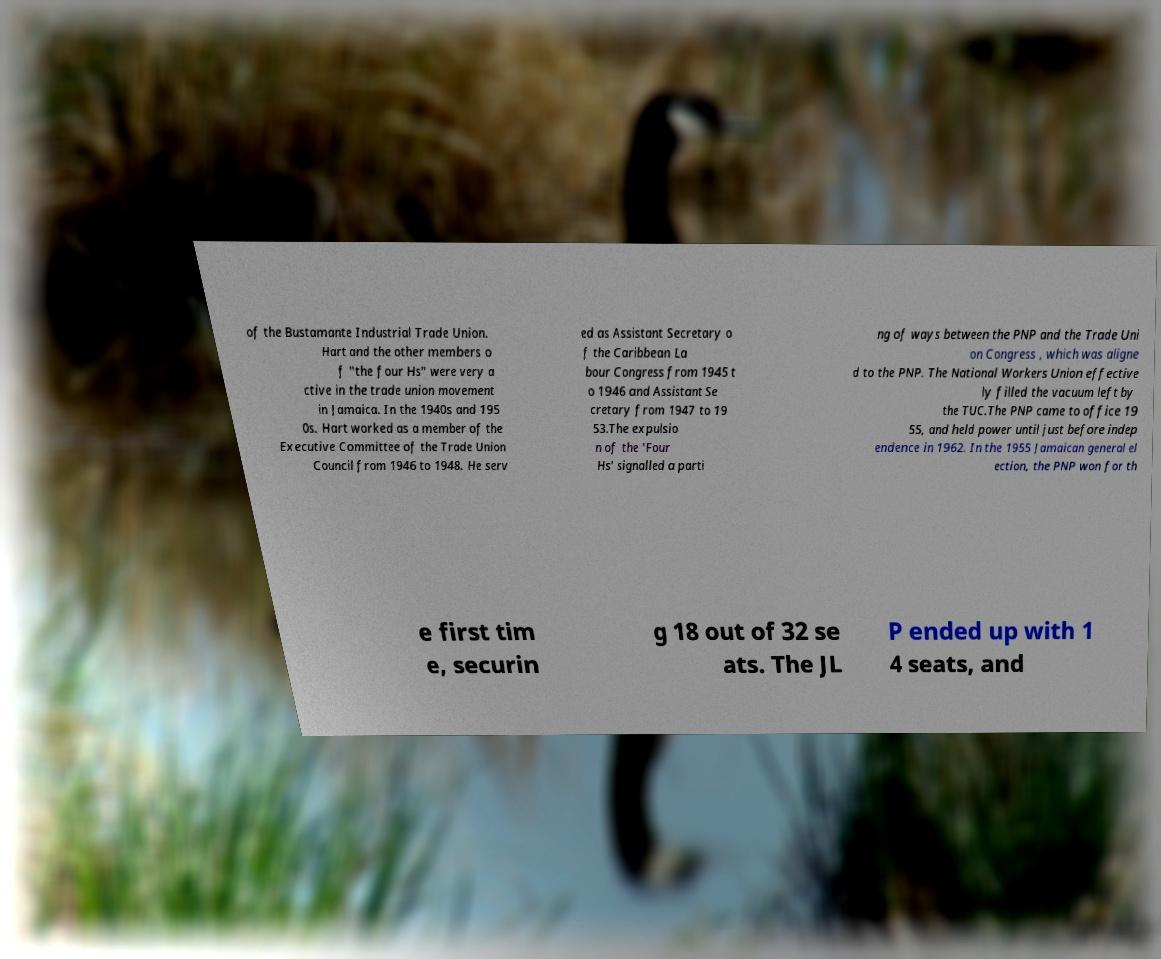There's text embedded in this image that I need extracted. Can you transcribe it verbatim? of the Bustamante Industrial Trade Union. Hart and the other members o f "the four Hs" were very a ctive in the trade union movement in Jamaica. In the 1940s and 195 0s. Hart worked as a member of the Executive Committee of the Trade Union Council from 1946 to 1948. He serv ed as Assistant Secretary o f the Caribbean La bour Congress from 1945 t o 1946 and Assistant Se cretary from 1947 to 19 53.The expulsio n of the 'Four Hs' signalled a parti ng of ways between the PNP and the Trade Uni on Congress , which was aligne d to the PNP. The National Workers Union effective ly filled the vacuum left by the TUC.The PNP came to office 19 55, and held power until just before indep endence in 1962. In the 1955 Jamaican general el ection, the PNP won for th e first tim e, securin g 18 out of 32 se ats. The JL P ended up with 1 4 seats, and 